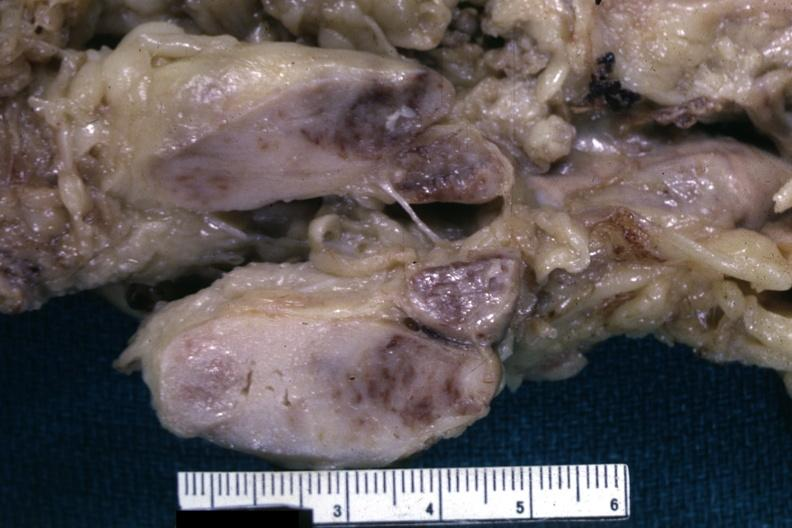s liver lesion lymphoma?
Answer the question using a single word or phrase. Yes 